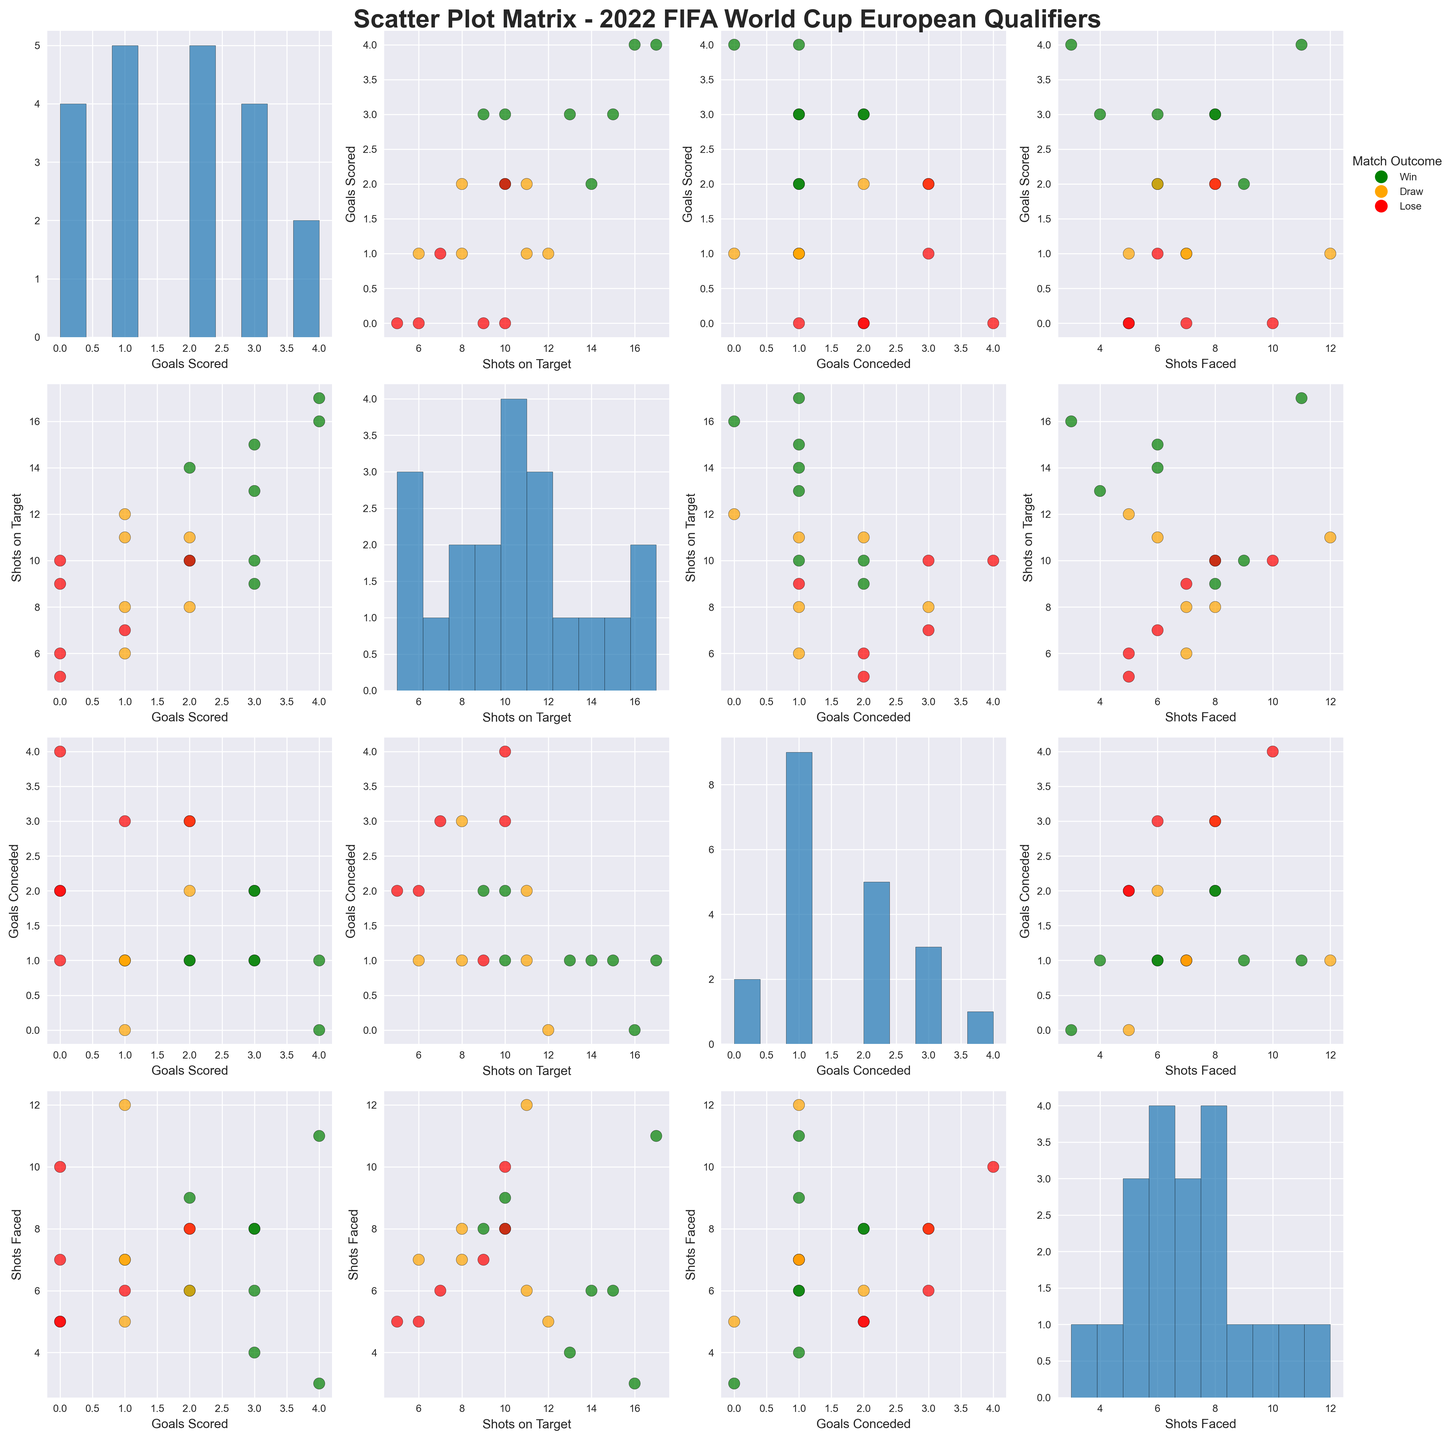Which team had the highest number of Goals Scored? By looking at the scatter plots, find the data point with the highest value on the "Goals Scored" axis. Austria stands out with 4 goals scored.
Answer: Austria Which teams had the highest and lowest Shots on Target in matches they won? From the scatter plots, compare the "Shots on Target" values among teams with green-colored dots (indicating a win). Austria had the highest Shots on Target (17), while Denmark had one of the lowest (10).
Answer: Austria and Denmark How many teams did not score any goals? Check the histogram for "Goals Scored" and count the number of bars or points at 0. There are four teams that didn't score any goals.
Answer: Four What is the average number of Goals Conceded in matches that were lost? From the scatter plots, identify the red-colored dots (indicating a loss) and average their "Goals Conceded" values. The teams and their Goals Conceded values are Spain (1), Switzerland (2), Sweden (3), Scotland (4), Norway (3), and Czech Republic (2). The average is (1+2+3+4+3+2)/6 = 2.5.
Answer: 2.5 Which teams scored more goals than they conceded? For each team, compare the "Goals Scored" and "Goals Conceded" values. Teams that have higher "Goals Scored" values than "Goals Conceded" include England, France, Germany, Italy, Netherlands, Denmark, Croatia, Russia, and Austria.
Answer: England, France, Germany, Italy, Netherlands, Denmark, Croatia, Russia, Austria Which type of match outcome is associated with the highest average Shots Faced? Calculate the average "Shots Faced" for each match outcome by averaging the relevant data points. Green (win), orange (draw), and red (lose) dots represent different outcomes. Wins had lower averages compared to losses, where Scotland faced 10 shots, indicating losses have higher average "Shots Faced".
Answer: Lose In which plotting area (i.e., "Goals Scored" vs "Shots Faced") are all the winning teams positioned lower on the "Shots Faced" axis? Examine the "Goals Scored" vs "Shots Faced" scatter plot. Green-colored dots (indicating wins) appear at lower "Shots Faced" values generally below 8.
Answer: "Goals Scored" vs "Shots Faced" Are there more draws or losses with a high number of Shots on Target? Compare the number of orange- and red-colored dots at higher "Shots on Target" values. Draws (orange) are seen in higher numbers in the 10-15 range, whereas losses (red) do not appear as frequently.
Answer: Draws 